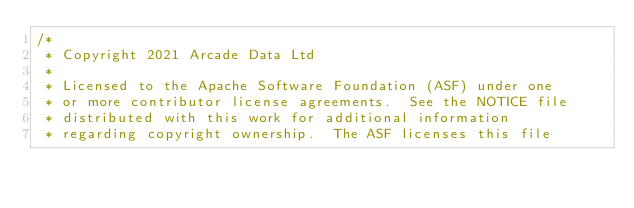<code> <loc_0><loc_0><loc_500><loc_500><_Java_>/*
 * Copyright 2021 Arcade Data Ltd
 *
 * Licensed to the Apache Software Foundation (ASF) under one
 * or more contributor license agreements.  See the NOTICE file
 * distributed with this work for additional information
 * regarding copyright ownership.  The ASF licenses this file</code> 